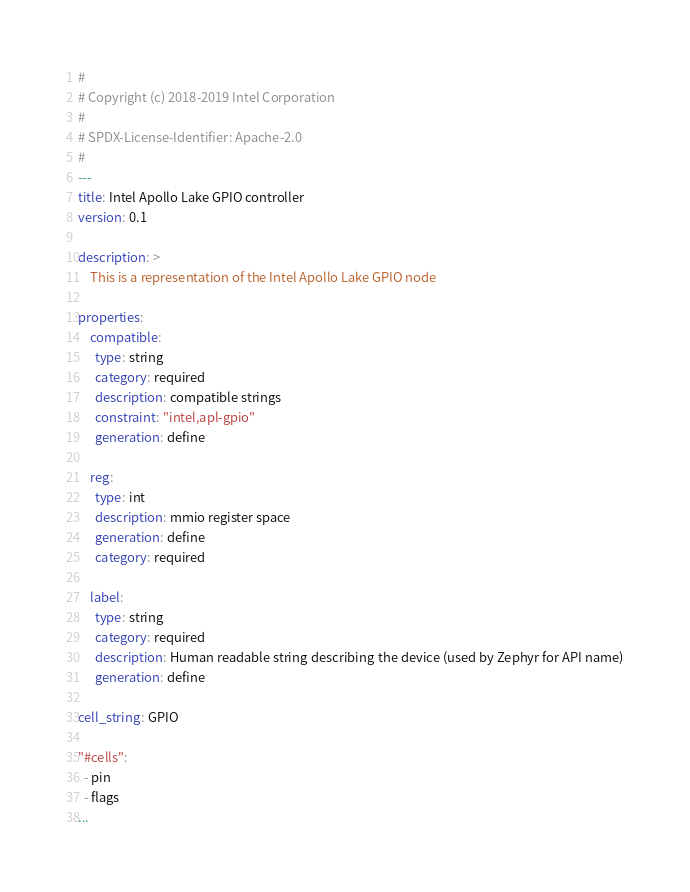Convert code to text. <code><loc_0><loc_0><loc_500><loc_500><_YAML_>#
# Copyright (c) 2018-2019 Intel Corporation
#
# SPDX-License-Identifier: Apache-2.0
#
---
title: Intel Apollo Lake GPIO controller
version: 0.1

description: >
    This is a representation of the Intel Apollo Lake GPIO node

properties:
    compatible:
      type: string
      category: required
      description: compatible strings
      constraint: "intel,apl-gpio"
      generation: define

    reg:
      type: int
      description: mmio register space
      generation: define
      category: required

    label:
      type: string
      category: required
      description: Human readable string describing the device (used by Zephyr for API name)
      generation: define

cell_string: GPIO

"#cells":
  - pin
  - flags
...
</code> 